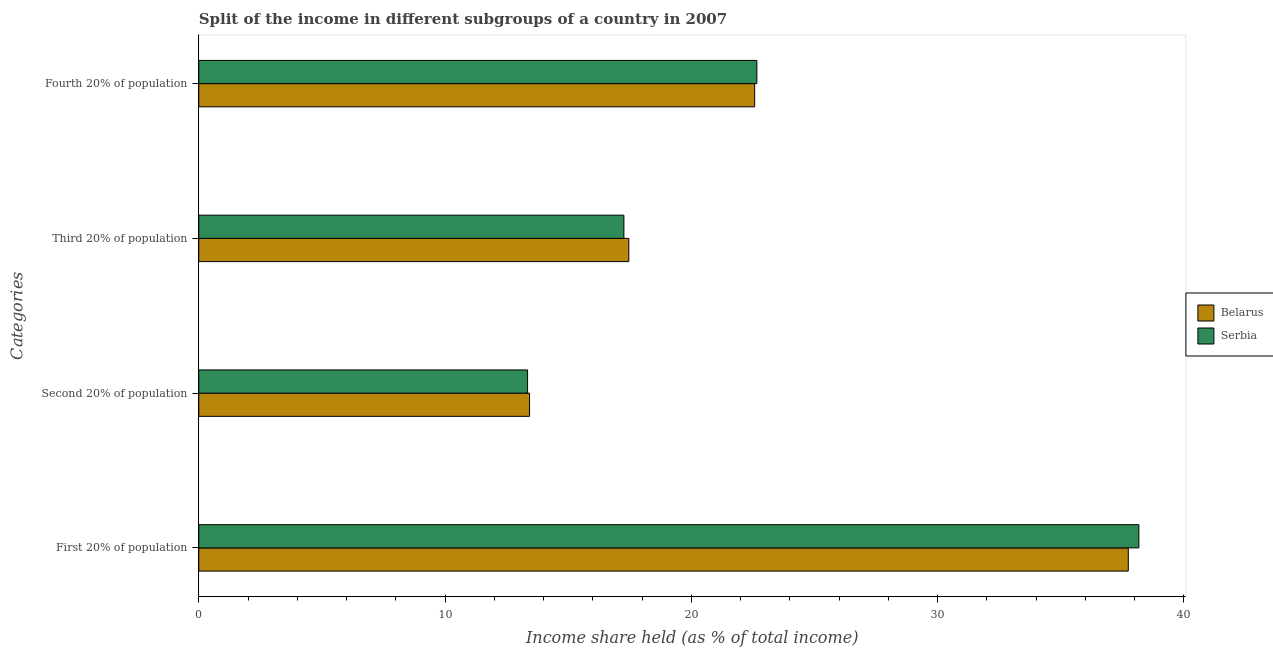How many different coloured bars are there?
Make the answer very short. 2. Are the number of bars on each tick of the Y-axis equal?
Give a very brief answer. Yes. How many bars are there on the 3rd tick from the bottom?
Your response must be concise. 2. What is the label of the 1st group of bars from the top?
Your answer should be very brief. Fourth 20% of population. What is the share of the income held by third 20% of the population in Serbia?
Your response must be concise. 17.26. Across all countries, what is the maximum share of the income held by second 20% of the population?
Give a very brief answer. 13.43. Across all countries, what is the minimum share of the income held by third 20% of the population?
Provide a short and direct response. 17.26. In which country was the share of the income held by fourth 20% of the population maximum?
Provide a short and direct response. Serbia. In which country was the share of the income held by fourth 20% of the population minimum?
Make the answer very short. Belarus. What is the total share of the income held by third 20% of the population in the graph?
Your response must be concise. 34.72. What is the difference between the share of the income held by first 20% of the population in Belarus and that in Serbia?
Your response must be concise. -0.43. What is the difference between the share of the income held by fourth 20% of the population in Serbia and the share of the income held by third 20% of the population in Belarus?
Provide a succinct answer. 5.2. What is the average share of the income held by third 20% of the population per country?
Your answer should be very brief. 17.36. What is the difference between the share of the income held by third 20% of the population and share of the income held by first 20% of the population in Serbia?
Keep it short and to the point. -20.91. In how many countries, is the share of the income held by fourth 20% of the population greater than 12 %?
Provide a short and direct response. 2. What is the ratio of the share of the income held by second 20% of the population in Serbia to that in Belarus?
Offer a terse response. 0.99. Is the share of the income held by fourth 20% of the population in Serbia less than that in Belarus?
Your answer should be compact. No. Is the difference between the share of the income held by fourth 20% of the population in Serbia and Belarus greater than the difference between the share of the income held by third 20% of the population in Serbia and Belarus?
Give a very brief answer. Yes. What is the difference between the highest and the second highest share of the income held by fourth 20% of the population?
Your answer should be compact. 0.09. What is the difference between the highest and the lowest share of the income held by third 20% of the population?
Provide a short and direct response. 0.2. What does the 2nd bar from the top in First 20% of population represents?
Make the answer very short. Belarus. What does the 2nd bar from the bottom in First 20% of population represents?
Ensure brevity in your answer.  Serbia. Is it the case that in every country, the sum of the share of the income held by first 20% of the population and share of the income held by second 20% of the population is greater than the share of the income held by third 20% of the population?
Provide a succinct answer. Yes. How many bars are there?
Provide a short and direct response. 8. How many countries are there in the graph?
Ensure brevity in your answer.  2. What is the difference between two consecutive major ticks on the X-axis?
Offer a terse response. 10. Does the graph contain any zero values?
Offer a terse response. No. Does the graph contain grids?
Provide a succinct answer. No. Where does the legend appear in the graph?
Your response must be concise. Center right. What is the title of the graph?
Provide a succinct answer. Split of the income in different subgroups of a country in 2007. Does "Benin" appear as one of the legend labels in the graph?
Keep it short and to the point. No. What is the label or title of the X-axis?
Provide a succinct answer. Income share held (as % of total income). What is the label or title of the Y-axis?
Keep it short and to the point. Categories. What is the Income share held (as % of total income) in Belarus in First 20% of population?
Offer a terse response. 37.74. What is the Income share held (as % of total income) in Serbia in First 20% of population?
Your response must be concise. 38.17. What is the Income share held (as % of total income) in Belarus in Second 20% of population?
Offer a very short reply. 13.43. What is the Income share held (as % of total income) of Serbia in Second 20% of population?
Make the answer very short. 13.35. What is the Income share held (as % of total income) in Belarus in Third 20% of population?
Offer a terse response. 17.46. What is the Income share held (as % of total income) of Serbia in Third 20% of population?
Your answer should be compact. 17.26. What is the Income share held (as % of total income) of Belarus in Fourth 20% of population?
Give a very brief answer. 22.57. What is the Income share held (as % of total income) in Serbia in Fourth 20% of population?
Offer a very short reply. 22.66. Across all Categories, what is the maximum Income share held (as % of total income) of Belarus?
Offer a terse response. 37.74. Across all Categories, what is the maximum Income share held (as % of total income) of Serbia?
Your answer should be very brief. 38.17. Across all Categories, what is the minimum Income share held (as % of total income) in Belarus?
Ensure brevity in your answer.  13.43. Across all Categories, what is the minimum Income share held (as % of total income) in Serbia?
Provide a succinct answer. 13.35. What is the total Income share held (as % of total income) in Belarus in the graph?
Ensure brevity in your answer.  91.2. What is the total Income share held (as % of total income) in Serbia in the graph?
Provide a short and direct response. 91.44. What is the difference between the Income share held (as % of total income) of Belarus in First 20% of population and that in Second 20% of population?
Make the answer very short. 24.31. What is the difference between the Income share held (as % of total income) of Serbia in First 20% of population and that in Second 20% of population?
Provide a succinct answer. 24.82. What is the difference between the Income share held (as % of total income) of Belarus in First 20% of population and that in Third 20% of population?
Provide a succinct answer. 20.28. What is the difference between the Income share held (as % of total income) of Serbia in First 20% of population and that in Third 20% of population?
Ensure brevity in your answer.  20.91. What is the difference between the Income share held (as % of total income) of Belarus in First 20% of population and that in Fourth 20% of population?
Keep it short and to the point. 15.17. What is the difference between the Income share held (as % of total income) in Serbia in First 20% of population and that in Fourth 20% of population?
Provide a short and direct response. 15.51. What is the difference between the Income share held (as % of total income) of Belarus in Second 20% of population and that in Third 20% of population?
Offer a very short reply. -4.03. What is the difference between the Income share held (as % of total income) in Serbia in Second 20% of population and that in Third 20% of population?
Your answer should be compact. -3.91. What is the difference between the Income share held (as % of total income) of Belarus in Second 20% of population and that in Fourth 20% of population?
Offer a very short reply. -9.14. What is the difference between the Income share held (as % of total income) of Serbia in Second 20% of population and that in Fourth 20% of population?
Provide a short and direct response. -9.31. What is the difference between the Income share held (as % of total income) in Belarus in Third 20% of population and that in Fourth 20% of population?
Your response must be concise. -5.11. What is the difference between the Income share held (as % of total income) of Belarus in First 20% of population and the Income share held (as % of total income) of Serbia in Second 20% of population?
Provide a short and direct response. 24.39. What is the difference between the Income share held (as % of total income) in Belarus in First 20% of population and the Income share held (as % of total income) in Serbia in Third 20% of population?
Ensure brevity in your answer.  20.48. What is the difference between the Income share held (as % of total income) of Belarus in First 20% of population and the Income share held (as % of total income) of Serbia in Fourth 20% of population?
Offer a terse response. 15.08. What is the difference between the Income share held (as % of total income) in Belarus in Second 20% of population and the Income share held (as % of total income) in Serbia in Third 20% of population?
Provide a short and direct response. -3.83. What is the difference between the Income share held (as % of total income) in Belarus in Second 20% of population and the Income share held (as % of total income) in Serbia in Fourth 20% of population?
Ensure brevity in your answer.  -9.23. What is the average Income share held (as % of total income) in Belarus per Categories?
Ensure brevity in your answer.  22.8. What is the average Income share held (as % of total income) in Serbia per Categories?
Offer a very short reply. 22.86. What is the difference between the Income share held (as % of total income) in Belarus and Income share held (as % of total income) in Serbia in First 20% of population?
Give a very brief answer. -0.43. What is the difference between the Income share held (as % of total income) in Belarus and Income share held (as % of total income) in Serbia in Fourth 20% of population?
Ensure brevity in your answer.  -0.09. What is the ratio of the Income share held (as % of total income) of Belarus in First 20% of population to that in Second 20% of population?
Your answer should be very brief. 2.81. What is the ratio of the Income share held (as % of total income) in Serbia in First 20% of population to that in Second 20% of population?
Give a very brief answer. 2.86. What is the ratio of the Income share held (as % of total income) in Belarus in First 20% of population to that in Third 20% of population?
Provide a short and direct response. 2.16. What is the ratio of the Income share held (as % of total income) of Serbia in First 20% of population to that in Third 20% of population?
Offer a terse response. 2.21. What is the ratio of the Income share held (as % of total income) of Belarus in First 20% of population to that in Fourth 20% of population?
Your response must be concise. 1.67. What is the ratio of the Income share held (as % of total income) in Serbia in First 20% of population to that in Fourth 20% of population?
Provide a succinct answer. 1.68. What is the ratio of the Income share held (as % of total income) of Belarus in Second 20% of population to that in Third 20% of population?
Offer a very short reply. 0.77. What is the ratio of the Income share held (as % of total income) in Serbia in Second 20% of population to that in Third 20% of population?
Make the answer very short. 0.77. What is the ratio of the Income share held (as % of total income) of Belarus in Second 20% of population to that in Fourth 20% of population?
Offer a terse response. 0.59. What is the ratio of the Income share held (as % of total income) of Serbia in Second 20% of population to that in Fourth 20% of population?
Your response must be concise. 0.59. What is the ratio of the Income share held (as % of total income) of Belarus in Third 20% of population to that in Fourth 20% of population?
Provide a short and direct response. 0.77. What is the ratio of the Income share held (as % of total income) of Serbia in Third 20% of population to that in Fourth 20% of population?
Offer a very short reply. 0.76. What is the difference between the highest and the second highest Income share held (as % of total income) of Belarus?
Give a very brief answer. 15.17. What is the difference between the highest and the second highest Income share held (as % of total income) in Serbia?
Provide a succinct answer. 15.51. What is the difference between the highest and the lowest Income share held (as % of total income) of Belarus?
Your response must be concise. 24.31. What is the difference between the highest and the lowest Income share held (as % of total income) of Serbia?
Provide a succinct answer. 24.82. 